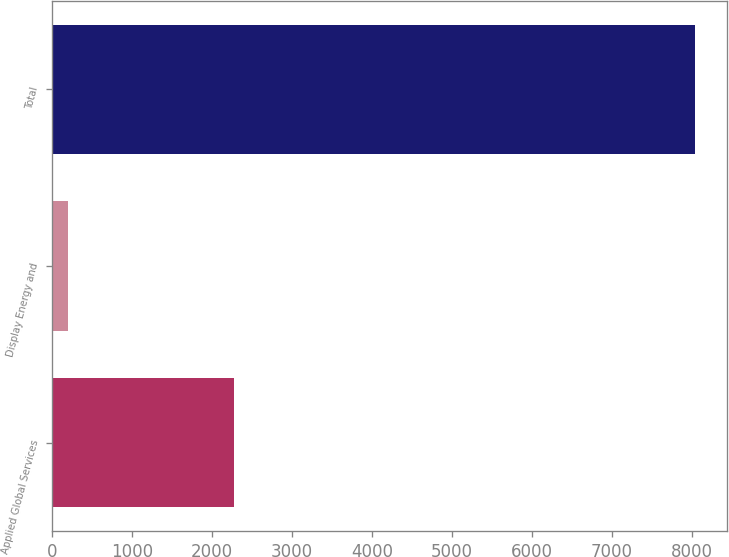Convert chart. <chart><loc_0><loc_0><loc_500><loc_500><bar_chart><fcel>Applied Global Services<fcel>Display Energy and<fcel>Total<nl><fcel>2274<fcel>195<fcel>8037<nl></chart> 